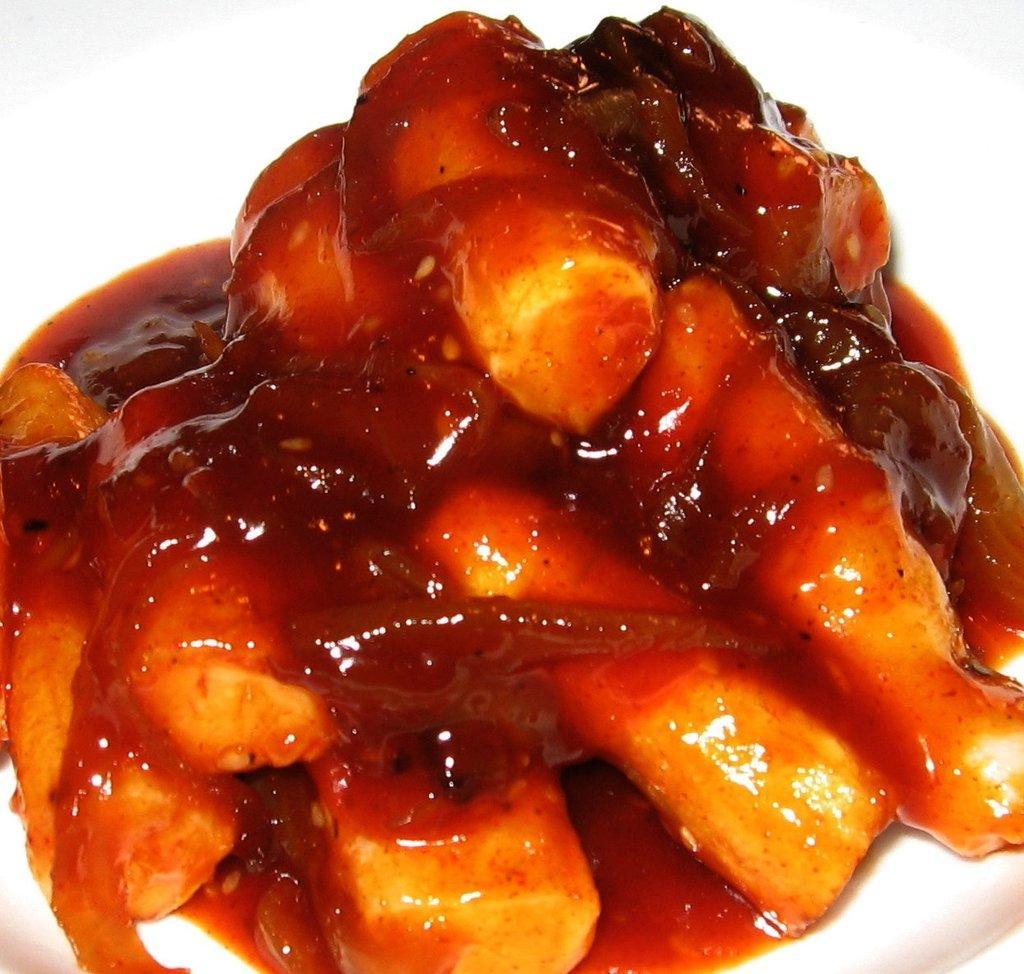Please provide a concise description of this image. In this image we can see food items on a platform. 